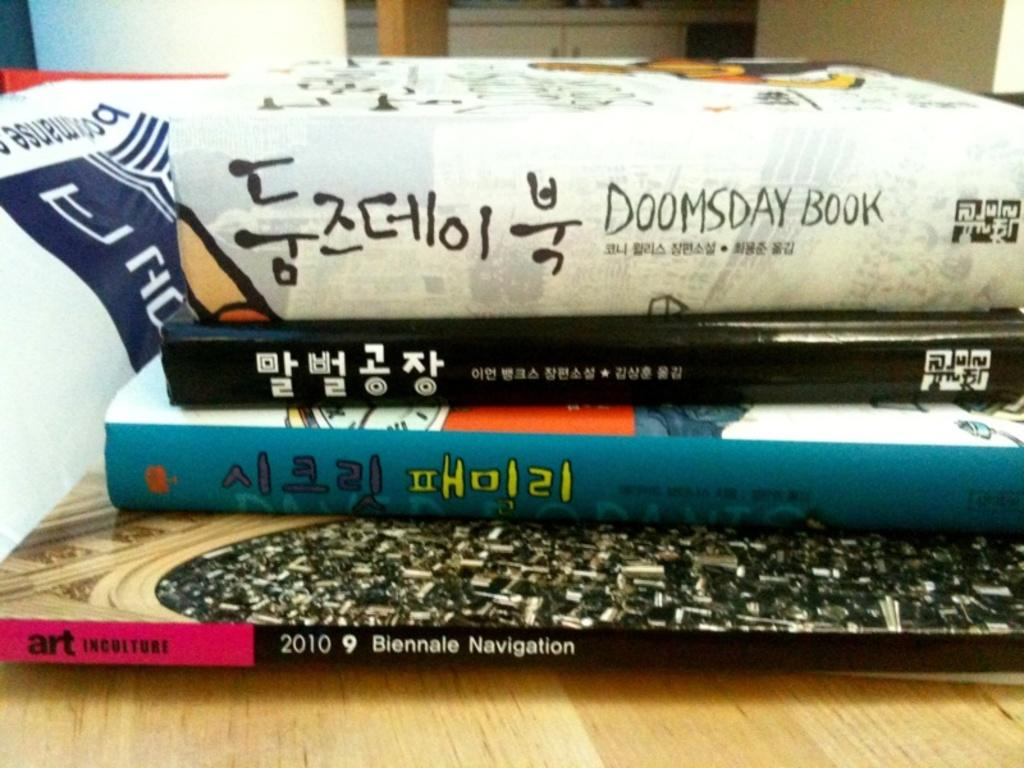<image>
Create a compact narrative representing the image presented. Four books stacked on a table with Doomsday book on the top. 